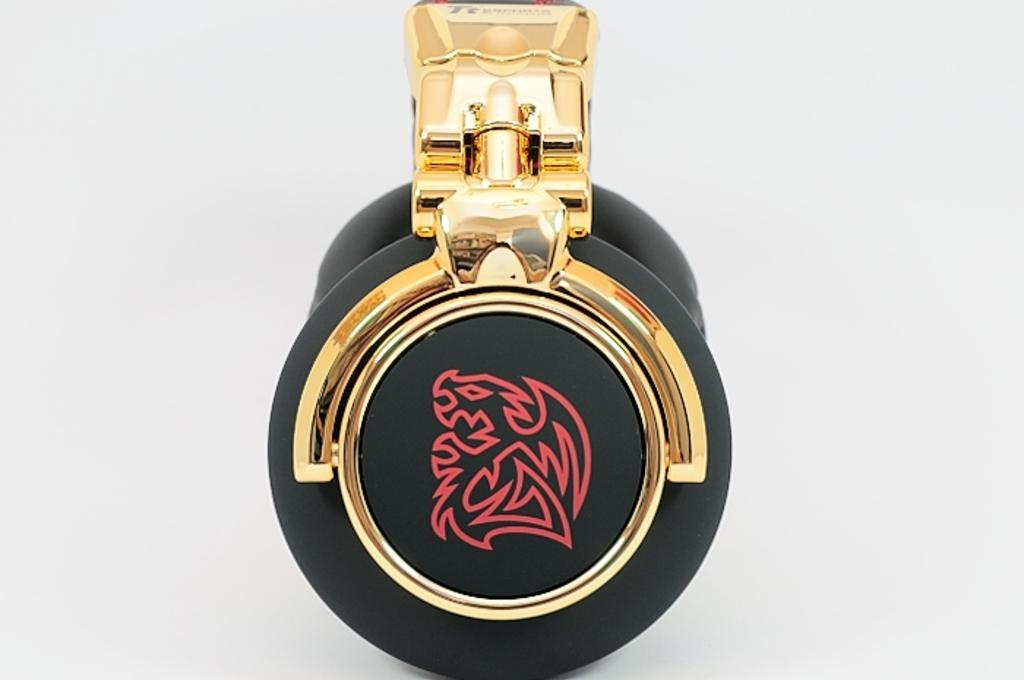What is the color of the main object in the image? The main object in the image is black. What is on top of the black object? There is a metal object on the black object. What color is the background of the image? The background of the image is white. Can you see a goat in the image? No, there is no goat present in the image. Is the black object a bomb in the image? No, the black object is not a bomb; it is simply a black object with a metal object on top. 